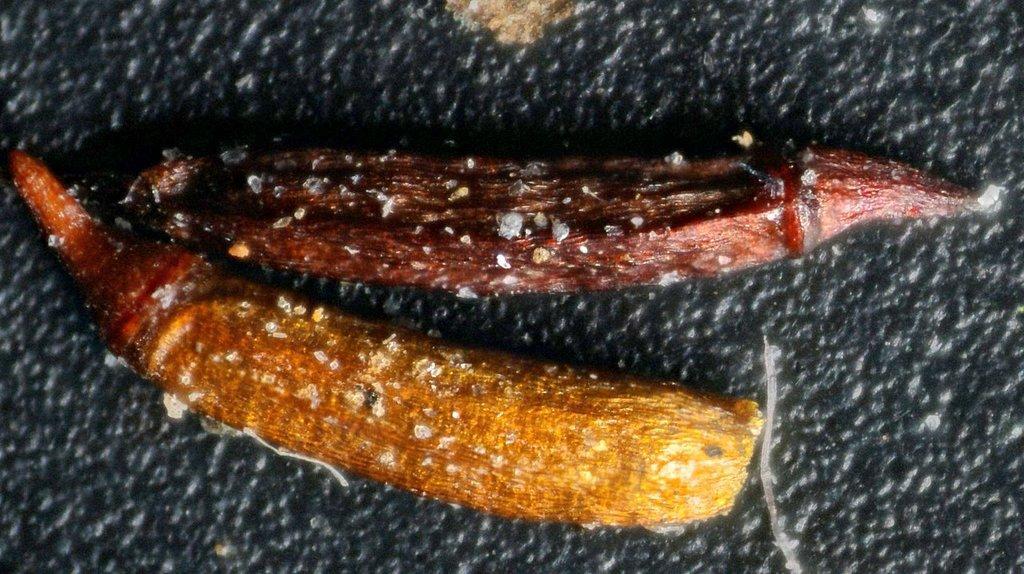Describe this image in one or two sentences. In this picture, those are looking like some food items on a black object. 